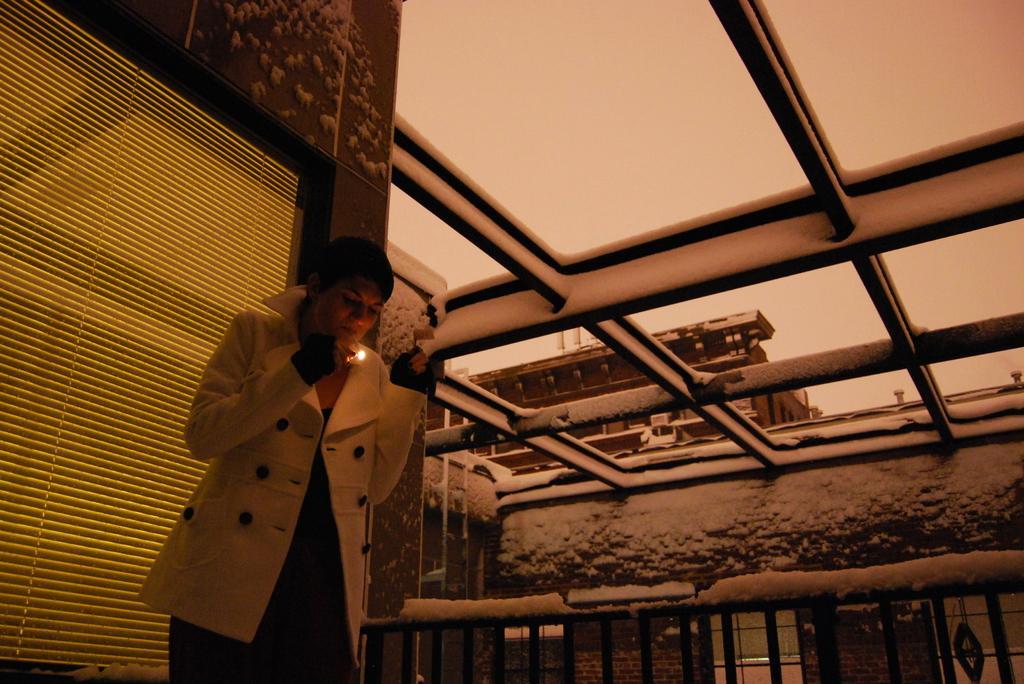Could you give a brief overview of what you see in this image? This image is taken outdoors. On the left side of the image there is a building with a wall and a window blind. In the middle of the image a woman is standing on the floor and she is holding a torch in her hand. On the right side of the image there is a house and it is covered with snow. 